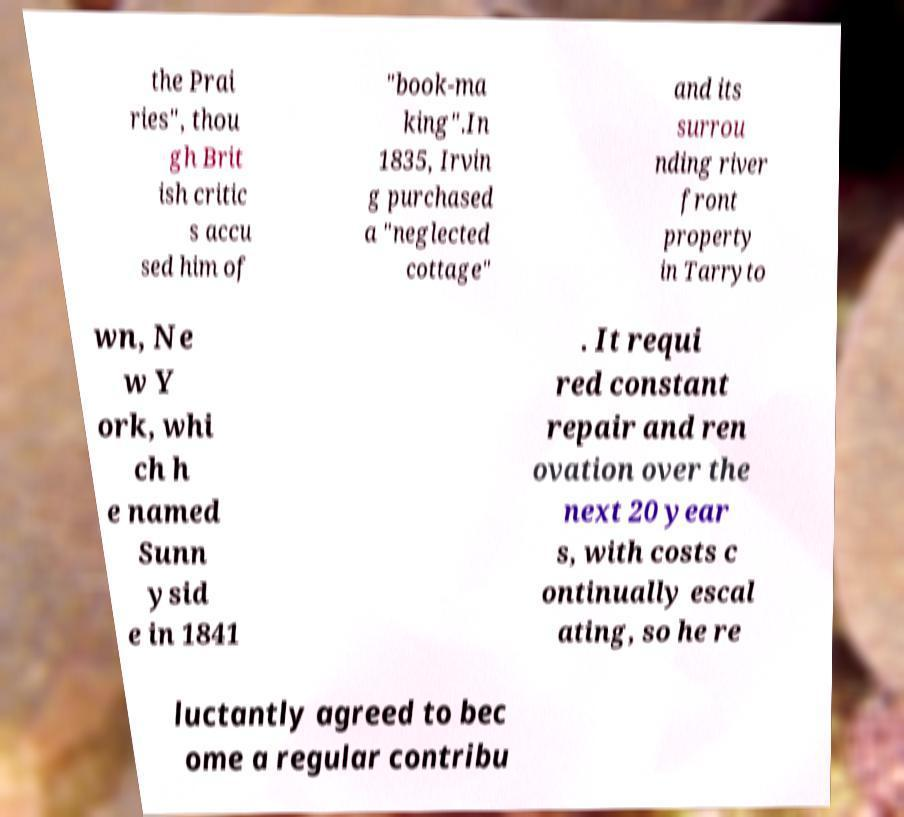Can you read and provide the text displayed in the image?This photo seems to have some interesting text. Can you extract and type it out for me? the Prai ries", thou gh Brit ish critic s accu sed him of "book-ma king".In 1835, Irvin g purchased a "neglected cottage" and its surrou nding river front property in Tarryto wn, Ne w Y ork, whi ch h e named Sunn ysid e in 1841 . It requi red constant repair and ren ovation over the next 20 year s, with costs c ontinually escal ating, so he re luctantly agreed to bec ome a regular contribu 